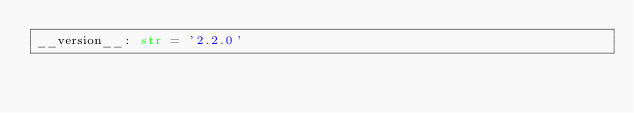<code> <loc_0><loc_0><loc_500><loc_500><_Python_>__version__: str = '2.2.0'
</code> 